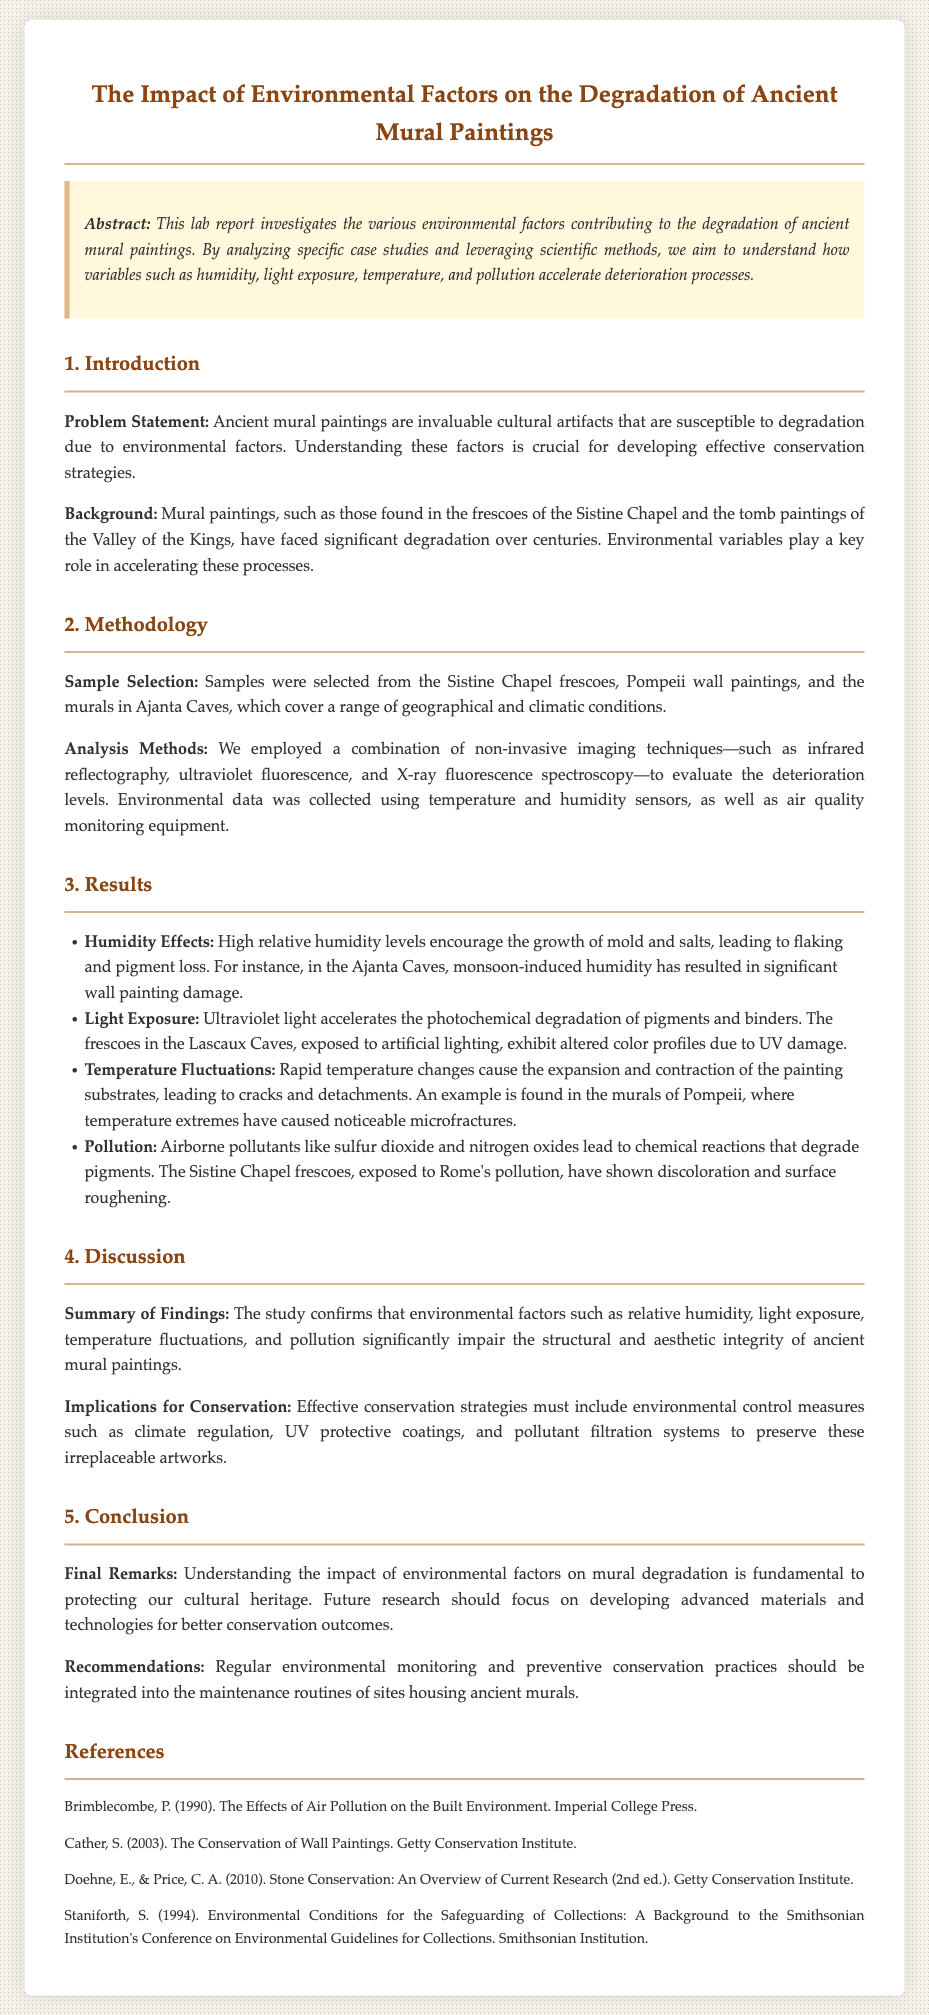What is the main focus of the study? The main focus of the study is to investigate the various environmental factors contributing to the degradation of ancient mural paintings.
Answer: environmental factors Which mural paintings were selected as samples? The samples were selected from the Sistine Chapel frescoes, Pompeii wall paintings, and the murals in Ajanta Caves.
Answer: Sistine Chapel frescoes, Pompeii wall paintings, Ajanta Caves What accelerated degradation factor was highlighted for the Ajanta Caves? The report highlights that monsoon-induced humidity has resulted in significant wall painting damage in the Ajanta Caves.
Answer: monsoon-induced humidity What type of light damage was observed in the Lascaux Caves? The frescoes in the Lascaux Caves exhibited altered color profiles due to UV damage from artificial lighting.
Answer: UV damage What does the report suggest for effective conservation strategies? Effective conservation strategies must include environmental control measures such as climate regulation, UV protective coatings, and pollutant filtration systems.
Answer: environmental control measures 